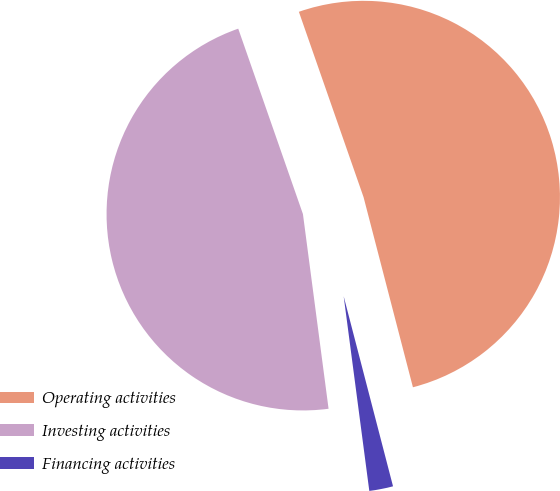<chart> <loc_0><loc_0><loc_500><loc_500><pie_chart><fcel>Operating activities<fcel>Investing activities<fcel>Financing activities<nl><fcel>51.3%<fcel>46.74%<fcel>1.96%<nl></chart> 